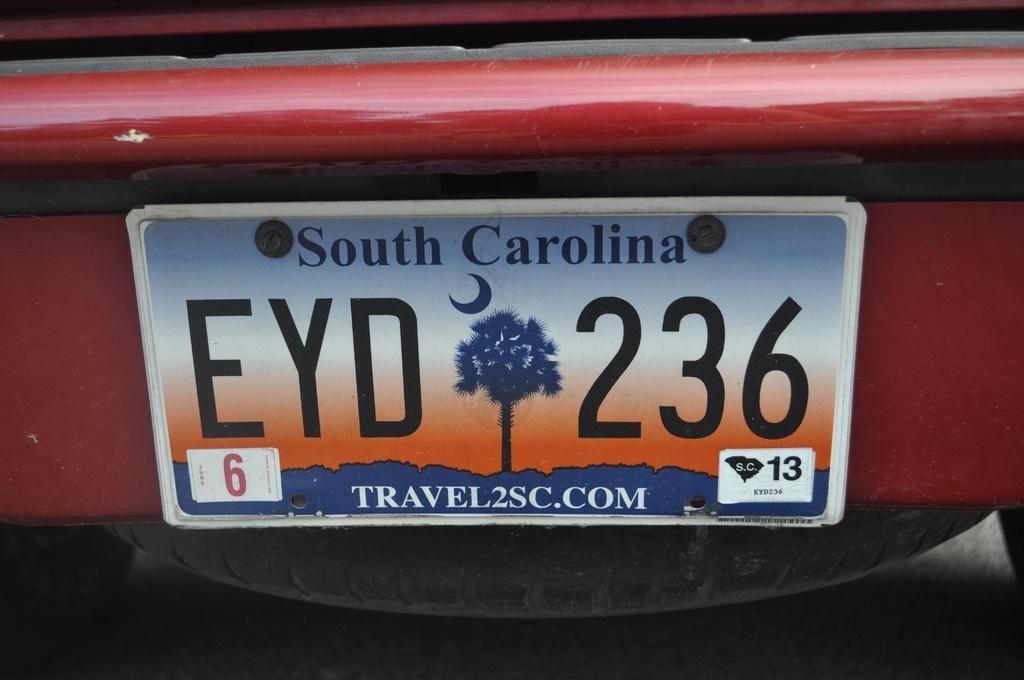What state is that car from?
Provide a short and direct response. South carolina. What is the website for south carolina?
Your response must be concise. Travel2sc.com. 